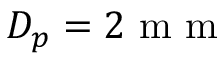<formula> <loc_0><loc_0><loc_500><loc_500>D _ { p } = 2 m m</formula> 